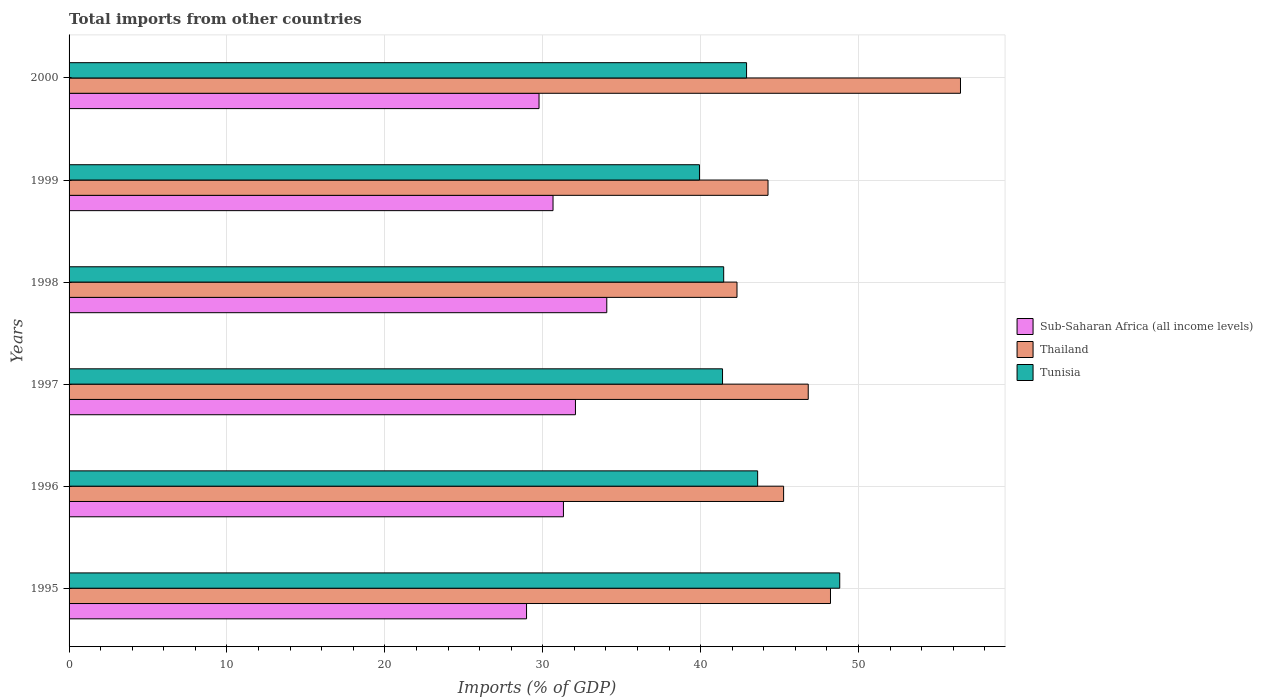How many different coloured bars are there?
Keep it short and to the point. 3. How many groups of bars are there?
Provide a short and direct response. 6. Are the number of bars per tick equal to the number of legend labels?
Keep it short and to the point. Yes. How many bars are there on the 1st tick from the top?
Ensure brevity in your answer.  3. What is the label of the 5th group of bars from the top?
Your answer should be compact. 1996. What is the total imports in Thailand in 1999?
Your answer should be compact. 44.27. Across all years, what is the maximum total imports in Sub-Saharan Africa (all income levels)?
Offer a terse response. 34.06. Across all years, what is the minimum total imports in Sub-Saharan Africa (all income levels)?
Provide a short and direct response. 28.97. In which year was the total imports in Thailand maximum?
Give a very brief answer. 2000. In which year was the total imports in Sub-Saharan Africa (all income levels) minimum?
Your response must be concise. 1995. What is the total total imports in Sub-Saharan Africa (all income levels) in the graph?
Your answer should be very brief. 186.83. What is the difference between the total imports in Thailand in 1995 and that in 1997?
Your response must be concise. 1.41. What is the difference between the total imports in Sub-Saharan Africa (all income levels) in 1996 and the total imports in Thailand in 1998?
Your answer should be very brief. -10.99. What is the average total imports in Tunisia per year?
Make the answer very short. 43.02. In the year 1999, what is the difference between the total imports in Sub-Saharan Africa (all income levels) and total imports in Tunisia?
Offer a terse response. -9.27. What is the ratio of the total imports in Sub-Saharan Africa (all income levels) in 1997 to that in 2000?
Provide a short and direct response. 1.08. Is the total imports in Thailand in 1998 less than that in 1999?
Your response must be concise. Yes. What is the difference between the highest and the second highest total imports in Sub-Saharan Africa (all income levels)?
Your answer should be compact. 1.98. What is the difference between the highest and the lowest total imports in Sub-Saharan Africa (all income levels)?
Your answer should be compact. 5.08. What does the 1st bar from the top in 2000 represents?
Offer a terse response. Tunisia. What does the 2nd bar from the bottom in 1996 represents?
Provide a short and direct response. Thailand. How many years are there in the graph?
Your answer should be compact. 6. Are the values on the major ticks of X-axis written in scientific E-notation?
Offer a terse response. No. Does the graph contain grids?
Provide a short and direct response. Yes. How many legend labels are there?
Offer a very short reply. 3. How are the legend labels stacked?
Make the answer very short. Vertical. What is the title of the graph?
Keep it short and to the point. Total imports from other countries. Does "Sub-Saharan Africa (developing only)" appear as one of the legend labels in the graph?
Your answer should be very brief. No. What is the label or title of the X-axis?
Make the answer very short. Imports (% of GDP). What is the Imports (% of GDP) in Sub-Saharan Africa (all income levels) in 1995?
Give a very brief answer. 28.97. What is the Imports (% of GDP) in Thailand in 1995?
Your answer should be compact. 48.22. What is the Imports (% of GDP) in Tunisia in 1995?
Your answer should be very brief. 48.81. What is the Imports (% of GDP) in Sub-Saharan Africa (all income levels) in 1996?
Give a very brief answer. 31.31. What is the Imports (% of GDP) in Thailand in 1996?
Provide a short and direct response. 45.26. What is the Imports (% of GDP) of Tunisia in 1996?
Offer a very short reply. 43.61. What is the Imports (% of GDP) of Sub-Saharan Africa (all income levels) in 1997?
Keep it short and to the point. 32.07. What is the Imports (% of GDP) of Thailand in 1997?
Your response must be concise. 46.81. What is the Imports (% of GDP) in Tunisia in 1997?
Provide a succinct answer. 41.39. What is the Imports (% of GDP) of Sub-Saharan Africa (all income levels) in 1998?
Offer a terse response. 34.06. What is the Imports (% of GDP) in Thailand in 1998?
Your response must be concise. 42.3. What is the Imports (% of GDP) in Tunisia in 1998?
Make the answer very short. 41.46. What is the Imports (% of GDP) of Sub-Saharan Africa (all income levels) in 1999?
Offer a terse response. 30.65. What is the Imports (% of GDP) in Thailand in 1999?
Ensure brevity in your answer.  44.27. What is the Imports (% of GDP) in Tunisia in 1999?
Keep it short and to the point. 39.93. What is the Imports (% of GDP) in Sub-Saharan Africa (all income levels) in 2000?
Offer a terse response. 29.77. What is the Imports (% of GDP) of Thailand in 2000?
Offer a terse response. 56.46. What is the Imports (% of GDP) of Tunisia in 2000?
Offer a very short reply. 42.91. Across all years, what is the maximum Imports (% of GDP) in Sub-Saharan Africa (all income levels)?
Ensure brevity in your answer.  34.06. Across all years, what is the maximum Imports (% of GDP) in Thailand?
Provide a succinct answer. 56.46. Across all years, what is the maximum Imports (% of GDP) in Tunisia?
Your answer should be very brief. 48.81. Across all years, what is the minimum Imports (% of GDP) in Sub-Saharan Africa (all income levels)?
Give a very brief answer. 28.97. Across all years, what is the minimum Imports (% of GDP) in Thailand?
Offer a terse response. 42.3. Across all years, what is the minimum Imports (% of GDP) of Tunisia?
Your answer should be compact. 39.93. What is the total Imports (% of GDP) of Sub-Saharan Africa (all income levels) in the graph?
Ensure brevity in your answer.  186.83. What is the total Imports (% of GDP) of Thailand in the graph?
Provide a short and direct response. 283.32. What is the total Imports (% of GDP) of Tunisia in the graph?
Your answer should be compact. 258.1. What is the difference between the Imports (% of GDP) of Sub-Saharan Africa (all income levels) in 1995 and that in 1996?
Provide a short and direct response. -2.34. What is the difference between the Imports (% of GDP) of Thailand in 1995 and that in 1996?
Your answer should be very brief. 2.97. What is the difference between the Imports (% of GDP) in Tunisia in 1995 and that in 1996?
Provide a short and direct response. 5.2. What is the difference between the Imports (% of GDP) in Sub-Saharan Africa (all income levels) in 1995 and that in 1997?
Your answer should be compact. -3.1. What is the difference between the Imports (% of GDP) of Thailand in 1995 and that in 1997?
Offer a very short reply. 1.41. What is the difference between the Imports (% of GDP) in Tunisia in 1995 and that in 1997?
Give a very brief answer. 7.42. What is the difference between the Imports (% of GDP) in Sub-Saharan Africa (all income levels) in 1995 and that in 1998?
Make the answer very short. -5.08. What is the difference between the Imports (% of GDP) in Thailand in 1995 and that in 1998?
Your answer should be compact. 5.92. What is the difference between the Imports (% of GDP) of Tunisia in 1995 and that in 1998?
Offer a very short reply. 7.35. What is the difference between the Imports (% of GDP) in Sub-Saharan Africa (all income levels) in 1995 and that in 1999?
Provide a succinct answer. -1.68. What is the difference between the Imports (% of GDP) of Thailand in 1995 and that in 1999?
Your answer should be very brief. 3.96. What is the difference between the Imports (% of GDP) of Tunisia in 1995 and that in 1999?
Make the answer very short. 8.88. What is the difference between the Imports (% of GDP) of Sub-Saharan Africa (all income levels) in 1995 and that in 2000?
Keep it short and to the point. -0.79. What is the difference between the Imports (% of GDP) of Thailand in 1995 and that in 2000?
Keep it short and to the point. -8.23. What is the difference between the Imports (% of GDP) of Tunisia in 1995 and that in 2000?
Provide a succinct answer. 5.9. What is the difference between the Imports (% of GDP) in Sub-Saharan Africa (all income levels) in 1996 and that in 1997?
Keep it short and to the point. -0.76. What is the difference between the Imports (% of GDP) in Thailand in 1996 and that in 1997?
Your answer should be compact. -1.56. What is the difference between the Imports (% of GDP) in Tunisia in 1996 and that in 1997?
Ensure brevity in your answer.  2.22. What is the difference between the Imports (% of GDP) of Sub-Saharan Africa (all income levels) in 1996 and that in 1998?
Your answer should be very brief. -2.74. What is the difference between the Imports (% of GDP) of Thailand in 1996 and that in 1998?
Ensure brevity in your answer.  2.95. What is the difference between the Imports (% of GDP) of Tunisia in 1996 and that in 1998?
Provide a short and direct response. 2.15. What is the difference between the Imports (% of GDP) of Sub-Saharan Africa (all income levels) in 1996 and that in 1999?
Provide a succinct answer. 0.66. What is the difference between the Imports (% of GDP) in Thailand in 1996 and that in 1999?
Provide a short and direct response. 0.99. What is the difference between the Imports (% of GDP) of Tunisia in 1996 and that in 1999?
Offer a terse response. 3.68. What is the difference between the Imports (% of GDP) in Sub-Saharan Africa (all income levels) in 1996 and that in 2000?
Your response must be concise. 1.55. What is the difference between the Imports (% of GDP) in Thailand in 1996 and that in 2000?
Keep it short and to the point. -11.2. What is the difference between the Imports (% of GDP) of Tunisia in 1996 and that in 2000?
Offer a terse response. 0.7. What is the difference between the Imports (% of GDP) in Sub-Saharan Africa (all income levels) in 1997 and that in 1998?
Your answer should be very brief. -1.98. What is the difference between the Imports (% of GDP) of Thailand in 1997 and that in 1998?
Give a very brief answer. 4.51. What is the difference between the Imports (% of GDP) of Tunisia in 1997 and that in 1998?
Provide a succinct answer. -0.07. What is the difference between the Imports (% of GDP) of Sub-Saharan Africa (all income levels) in 1997 and that in 1999?
Keep it short and to the point. 1.42. What is the difference between the Imports (% of GDP) in Thailand in 1997 and that in 1999?
Make the answer very short. 2.55. What is the difference between the Imports (% of GDP) of Tunisia in 1997 and that in 1999?
Your answer should be very brief. 1.46. What is the difference between the Imports (% of GDP) in Sub-Saharan Africa (all income levels) in 1997 and that in 2000?
Offer a terse response. 2.31. What is the difference between the Imports (% of GDP) of Thailand in 1997 and that in 2000?
Your response must be concise. -9.64. What is the difference between the Imports (% of GDP) in Tunisia in 1997 and that in 2000?
Your answer should be compact. -1.52. What is the difference between the Imports (% of GDP) of Sub-Saharan Africa (all income levels) in 1998 and that in 1999?
Offer a very short reply. 3.4. What is the difference between the Imports (% of GDP) of Thailand in 1998 and that in 1999?
Offer a very short reply. -1.96. What is the difference between the Imports (% of GDP) of Tunisia in 1998 and that in 1999?
Your answer should be compact. 1.53. What is the difference between the Imports (% of GDP) in Sub-Saharan Africa (all income levels) in 1998 and that in 2000?
Your response must be concise. 4.29. What is the difference between the Imports (% of GDP) of Thailand in 1998 and that in 2000?
Offer a terse response. -14.15. What is the difference between the Imports (% of GDP) in Tunisia in 1998 and that in 2000?
Keep it short and to the point. -1.45. What is the difference between the Imports (% of GDP) in Sub-Saharan Africa (all income levels) in 1999 and that in 2000?
Provide a short and direct response. 0.89. What is the difference between the Imports (% of GDP) in Thailand in 1999 and that in 2000?
Ensure brevity in your answer.  -12.19. What is the difference between the Imports (% of GDP) in Tunisia in 1999 and that in 2000?
Provide a short and direct response. -2.98. What is the difference between the Imports (% of GDP) in Sub-Saharan Africa (all income levels) in 1995 and the Imports (% of GDP) in Thailand in 1996?
Give a very brief answer. -16.28. What is the difference between the Imports (% of GDP) in Sub-Saharan Africa (all income levels) in 1995 and the Imports (% of GDP) in Tunisia in 1996?
Ensure brevity in your answer.  -14.64. What is the difference between the Imports (% of GDP) of Thailand in 1995 and the Imports (% of GDP) of Tunisia in 1996?
Offer a very short reply. 4.61. What is the difference between the Imports (% of GDP) of Sub-Saharan Africa (all income levels) in 1995 and the Imports (% of GDP) of Thailand in 1997?
Your response must be concise. -17.84. What is the difference between the Imports (% of GDP) in Sub-Saharan Africa (all income levels) in 1995 and the Imports (% of GDP) in Tunisia in 1997?
Provide a succinct answer. -12.41. What is the difference between the Imports (% of GDP) in Thailand in 1995 and the Imports (% of GDP) in Tunisia in 1997?
Make the answer very short. 6.84. What is the difference between the Imports (% of GDP) of Sub-Saharan Africa (all income levels) in 1995 and the Imports (% of GDP) of Thailand in 1998?
Offer a terse response. -13.33. What is the difference between the Imports (% of GDP) in Sub-Saharan Africa (all income levels) in 1995 and the Imports (% of GDP) in Tunisia in 1998?
Give a very brief answer. -12.49. What is the difference between the Imports (% of GDP) of Thailand in 1995 and the Imports (% of GDP) of Tunisia in 1998?
Your response must be concise. 6.76. What is the difference between the Imports (% of GDP) in Sub-Saharan Africa (all income levels) in 1995 and the Imports (% of GDP) in Thailand in 1999?
Offer a terse response. -15.29. What is the difference between the Imports (% of GDP) in Sub-Saharan Africa (all income levels) in 1995 and the Imports (% of GDP) in Tunisia in 1999?
Make the answer very short. -10.95. What is the difference between the Imports (% of GDP) of Thailand in 1995 and the Imports (% of GDP) of Tunisia in 1999?
Provide a succinct answer. 8.3. What is the difference between the Imports (% of GDP) of Sub-Saharan Africa (all income levels) in 1995 and the Imports (% of GDP) of Thailand in 2000?
Keep it short and to the point. -27.48. What is the difference between the Imports (% of GDP) of Sub-Saharan Africa (all income levels) in 1995 and the Imports (% of GDP) of Tunisia in 2000?
Ensure brevity in your answer.  -13.93. What is the difference between the Imports (% of GDP) in Thailand in 1995 and the Imports (% of GDP) in Tunisia in 2000?
Provide a short and direct response. 5.31. What is the difference between the Imports (% of GDP) of Sub-Saharan Africa (all income levels) in 1996 and the Imports (% of GDP) of Thailand in 1997?
Give a very brief answer. -15.5. What is the difference between the Imports (% of GDP) in Sub-Saharan Africa (all income levels) in 1996 and the Imports (% of GDP) in Tunisia in 1997?
Your answer should be compact. -10.08. What is the difference between the Imports (% of GDP) of Thailand in 1996 and the Imports (% of GDP) of Tunisia in 1997?
Provide a succinct answer. 3.87. What is the difference between the Imports (% of GDP) in Sub-Saharan Africa (all income levels) in 1996 and the Imports (% of GDP) in Thailand in 1998?
Offer a very short reply. -10.99. What is the difference between the Imports (% of GDP) of Sub-Saharan Africa (all income levels) in 1996 and the Imports (% of GDP) of Tunisia in 1998?
Make the answer very short. -10.15. What is the difference between the Imports (% of GDP) in Thailand in 1996 and the Imports (% of GDP) in Tunisia in 1998?
Your answer should be compact. 3.8. What is the difference between the Imports (% of GDP) of Sub-Saharan Africa (all income levels) in 1996 and the Imports (% of GDP) of Thailand in 1999?
Keep it short and to the point. -12.96. What is the difference between the Imports (% of GDP) in Sub-Saharan Africa (all income levels) in 1996 and the Imports (% of GDP) in Tunisia in 1999?
Your response must be concise. -8.61. What is the difference between the Imports (% of GDP) of Thailand in 1996 and the Imports (% of GDP) of Tunisia in 1999?
Provide a short and direct response. 5.33. What is the difference between the Imports (% of GDP) of Sub-Saharan Africa (all income levels) in 1996 and the Imports (% of GDP) of Thailand in 2000?
Provide a succinct answer. -25.15. What is the difference between the Imports (% of GDP) of Sub-Saharan Africa (all income levels) in 1996 and the Imports (% of GDP) of Tunisia in 2000?
Provide a succinct answer. -11.6. What is the difference between the Imports (% of GDP) of Thailand in 1996 and the Imports (% of GDP) of Tunisia in 2000?
Offer a terse response. 2.35. What is the difference between the Imports (% of GDP) of Sub-Saharan Africa (all income levels) in 1997 and the Imports (% of GDP) of Thailand in 1998?
Keep it short and to the point. -10.23. What is the difference between the Imports (% of GDP) of Sub-Saharan Africa (all income levels) in 1997 and the Imports (% of GDP) of Tunisia in 1998?
Provide a succinct answer. -9.39. What is the difference between the Imports (% of GDP) in Thailand in 1997 and the Imports (% of GDP) in Tunisia in 1998?
Your answer should be compact. 5.36. What is the difference between the Imports (% of GDP) of Sub-Saharan Africa (all income levels) in 1997 and the Imports (% of GDP) of Thailand in 1999?
Keep it short and to the point. -12.2. What is the difference between the Imports (% of GDP) of Sub-Saharan Africa (all income levels) in 1997 and the Imports (% of GDP) of Tunisia in 1999?
Your answer should be compact. -7.85. What is the difference between the Imports (% of GDP) of Thailand in 1997 and the Imports (% of GDP) of Tunisia in 1999?
Provide a succinct answer. 6.89. What is the difference between the Imports (% of GDP) of Sub-Saharan Africa (all income levels) in 1997 and the Imports (% of GDP) of Thailand in 2000?
Ensure brevity in your answer.  -24.39. What is the difference between the Imports (% of GDP) of Sub-Saharan Africa (all income levels) in 1997 and the Imports (% of GDP) of Tunisia in 2000?
Provide a succinct answer. -10.84. What is the difference between the Imports (% of GDP) in Thailand in 1997 and the Imports (% of GDP) in Tunisia in 2000?
Ensure brevity in your answer.  3.91. What is the difference between the Imports (% of GDP) of Sub-Saharan Africa (all income levels) in 1998 and the Imports (% of GDP) of Thailand in 1999?
Your answer should be compact. -10.21. What is the difference between the Imports (% of GDP) in Sub-Saharan Africa (all income levels) in 1998 and the Imports (% of GDP) in Tunisia in 1999?
Keep it short and to the point. -5.87. What is the difference between the Imports (% of GDP) of Thailand in 1998 and the Imports (% of GDP) of Tunisia in 1999?
Offer a very short reply. 2.38. What is the difference between the Imports (% of GDP) of Sub-Saharan Africa (all income levels) in 1998 and the Imports (% of GDP) of Thailand in 2000?
Provide a short and direct response. -22.4. What is the difference between the Imports (% of GDP) of Sub-Saharan Africa (all income levels) in 1998 and the Imports (% of GDP) of Tunisia in 2000?
Ensure brevity in your answer.  -8.85. What is the difference between the Imports (% of GDP) in Thailand in 1998 and the Imports (% of GDP) in Tunisia in 2000?
Provide a short and direct response. -0.61. What is the difference between the Imports (% of GDP) of Sub-Saharan Africa (all income levels) in 1999 and the Imports (% of GDP) of Thailand in 2000?
Make the answer very short. -25.81. What is the difference between the Imports (% of GDP) of Sub-Saharan Africa (all income levels) in 1999 and the Imports (% of GDP) of Tunisia in 2000?
Your answer should be compact. -12.26. What is the difference between the Imports (% of GDP) in Thailand in 1999 and the Imports (% of GDP) in Tunisia in 2000?
Offer a very short reply. 1.36. What is the average Imports (% of GDP) in Sub-Saharan Africa (all income levels) per year?
Ensure brevity in your answer.  31.14. What is the average Imports (% of GDP) of Thailand per year?
Offer a very short reply. 47.22. What is the average Imports (% of GDP) of Tunisia per year?
Your answer should be compact. 43.02. In the year 1995, what is the difference between the Imports (% of GDP) of Sub-Saharan Africa (all income levels) and Imports (% of GDP) of Thailand?
Provide a short and direct response. -19.25. In the year 1995, what is the difference between the Imports (% of GDP) in Sub-Saharan Africa (all income levels) and Imports (% of GDP) in Tunisia?
Offer a very short reply. -19.84. In the year 1995, what is the difference between the Imports (% of GDP) of Thailand and Imports (% of GDP) of Tunisia?
Provide a succinct answer. -0.59. In the year 1996, what is the difference between the Imports (% of GDP) of Sub-Saharan Africa (all income levels) and Imports (% of GDP) of Thailand?
Make the answer very short. -13.94. In the year 1996, what is the difference between the Imports (% of GDP) of Sub-Saharan Africa (all income levels) and Imports (% of GDP) of Tunisia?
Provide a succinct answer. -12.3. In the year 1996, what is the difference between the Imports (% of GDP) in Thailand and Imports (% of GDP) in Tunisia?
Your answer should be compact. 1.64. In the year 1997, what is the difference between the Imports (% of GDP) in Sub-Saharan Africa (all income levels) and Imports (% of GDP) in Thailand?
Ensure brevity in your answer.  -14.74. In the year 1997, what is the difference between the Imports (% of GDP) in Sub-Saharan Africa (all income levels) and Imports (% of GDP) in Tunisia?
Keep it short and to the point. -9.31. In the year 1997, what is the difference between the Imports (% of GDP) of Thailand and Imports (% of GDP) of Tunisia?
Offer a very short reply. 5.43. In the year 1998, what is the difference between the Imports (% of GDP) of Sub-Saharan Africa (all income levels) and Imports (% of GDP) of Thailand?
Make the answer very short. -8.25. In the year 1998, what is the difference between the Imports (% of GDP) in Sub-Saharan Africa (all income levels) and Imports (% of GDP) in Tunisia?
Your answer should be very brief. -7.4. In the year 1998, what is the difference between the Imports (% of GDP) of Thailand and Imports (% of GDP) of Tunisia?
Your response must be concise. 0.84. In the year 1999, what is the difference between the Imports (% of GDP) in Sub-Saharan Africa (all income levels) and Imports (% of GDP) in Thailand?
Keep it short and to the point. -13.62. In the year 1999, what is the difference between the Imports (% of GDP) of Sub-Saharan Africa (all income levels) and Imports (% of GDP) of Tunisia?
Provide a succinct answer. -9.27. In the year 1999, what is the difference between the Imports (% of GDP) in Thailand and Imports (% of GDP) in Tunisia?
Offer a terse response. 4.34. In the year 2000, what is the difference between the Imports (% of GDP) of Sub-Saharan Africa (all income levels) and Imports (% of GDP) of Thailand?
Offer a terse response. -26.69. In the year 2000, what is the difference between the Imports (% of GDP) in Sub-Saharan Africa (all income levels) and Imports (% of GDP) in Tunisia?
Your answer should be compact. -13.14. In the year 2000, what is the difference between the Imports (% of GDP) in Thailand and Imports (% of GDP) in Tunisia?
Ensure brevity in your answer.  13.55. What is the ratio of the Imports (% of GDP) in Sub-Saharan Africa (all income levels) in 1995 to that in 1996?
Provide a succinct answer. 0.93. What is the ratio of the Imports (% of GDP) of Thailand in 1995 to that in 1996?
Give a very brief answer. 1.07. What is the ratio of the Imports (% of GDP) in Tunisia in 1995 to that in 1996?
Your response must be concise. 1.12. What is the ratio of the Imports (% of GDP) in Sub-Saharan Africa (all income levels) in 1995 to that in 1997?
Offer a very short reply. 0.9. What is the ratio of the Imports (% of GDP) in Thailand in 1995 to that in 1997?
Your answer should be very brief. 1.03. What is the ratio of the Imports (% of GDP) in Tunisia in 1995 to that in 1997?
Your answer should be compact. 1.18. What is the ratio of the Imports (% of GDP) in Sub-Saharan Africa (all income levels) in 1995 to that in 1998?
Keep it short and to the point. 0.85. What is the ratio of the Imports (% of GDP) of Thailand in 1995 to that in 1998?
Provide a succinct answer. 1.14. What is the ratio of the Imports (% of GDP) in Tunisia in 1995 to that in 1998?
Make the answer very short. 1.18. What is the ratio of the Imports (% of GDP) of Sub-Saharan Africa (all income levels) in 1995 to that in 1999?
Keep it short and to the point. 0.95. What is the ratio of the Imports (% of GDP) of Thailand in 1995 to that in 1999?
Keep it short and to the point. 1.09. What is the ratio of the Imports (% of GDP) in Tunisia in 1995 to that in 1999?
Make the answer very short. 1.22. What is the ratio of the Imports (% of GDP) of Sub-Saharan Africa (all income levels) in 1995 to that in 2000?
Your answer should be compact. 0.97. What is the ratio of the Imports (% of GDP) in Thailand in 1995 to that in 2000?
Offer a very short reply. 0.85. What is the ratio of the Imports (% of GDP) of Tunisia in 1995 to that in 2000?
Offer a terse response. 1.14. What is the ratio of the Imports (% of GDP) in Sub-Saharan Africa (all income levels) in 1996 to that in 1997?
Provide a short and direct response. 0.98. What is the ratio of the Imports (% of GDP) in Thailand in 1996 to that in 1997?
Your answer should be compact. 0.97. What is the ratio of the Imports (% of GDP) in Tunisia in 1996 to that in 1997?
Keep it short and to the point. 1.05. What is the ratio of the Imports (% of GDP) of Sub-Saharan Africa (all income levels) in 1996 to that in 1998?
Give a very brief answer. 0.92. What is the ratio of the Imports (% of GDP) in Thailand in 1996 to that in 1998?
Your answer should be compact. 1.07. What is the ratio of the Imports (% of GDP) in Tunisia in 1996 to that in 1998?
Provide a succinct answer. 1.05. What is the ratio of the Imports (% of GDP) of Sub-Saharan Africa (all income levels) in 1996 to that in 1999?
Your answer should be compact. 1.02. What is the ratio of the Imports (% of GDP) in Thailand in 1996 to that in 1999?
Give a very brief answer. 1.02. What is the ratio of the Imports (% of GDP) of Tunisia in 1996 to that in 1999?
Your response must be concise. 1.09. What is the ratio of the Imports (% of GDP) in Sub-Saharan Africa (all income levels) in 1996 to that in 2000?
Your response must be concise. 1.05. What is the ratio of the Imports (% of GDP) of Thailand in 1996 to that in 2000?
Make the answer very short. 0.8. What is the ratio of the Imports (% of GDP) in Tunisia in 1996 to that in 2000?
Make the answer very short. 1.02. What is the ratio of the Imports (% of GDP) in Sub-Saharan Africa (all income levels) in 1997 to that in 1998?
Offer a terse response. 0.94. What is the ratio of the Imports (% of GDP) of Thailand in 1997 to that in 1998?
Ensure brevity in your answer.  1.11. What is the ratio of the Imports (% of GDP) of Sub-Saharan Africa (all income levels) in 1997 to that in 1999?
Keep it short and to the point. 1.05. What is the ratio of the Imports (% of GDP) in Thailand in 1997 to that in 1999?
Offer a terse response. 1.06. What is the ratio of the Imports (% of GDP) of Tunisia in 1997 to that in 1999?
Offer a very short reply. 1.04. What is the ratio of the Imports (% of GDP) of Sub-Saharan Africa (all income levels) in 1997 to that in 2000?
Keep it short and to the point. 1.08. What is the ratio of the Imports (% of GDP) in Thailand in 1997 to that in 2000?
Provide a short and direct response. 0.83. What is the ratio of the Imports (% of GDP) of Tunisia in 1997 to that in 2000?
Ensure brevity in your answer.  0.96. What is the ratio of the Imports (% of GDP) of Thailand in 1998 to that in 1999?
Give a very brief answer. 0.96. What is the ratio of the Imports (% of GDP) in Tunisia in 1998 to that in 1999?
Your response must be concise. 1.04. What is the ratio of the Imports (% of GDP) in Sub-Saharan Africa (all income levels) in 1998 to that in 2000?
Your answer should be compact. 1.14. What is the ratio of the Imports (% of GDP) in Thailand in 1998 to that in 2000?
Offer a very short reply. 0.75. What is the ratio of the Imports (% of GDP) of Tunisia in 1998 to that in 2000?
Provide a short and direct response. 0.97. What is the ratio of the Imports (% of GDP) in Sub-Saharan Africa (all income levels) in 1999 to that in 2000?
Make the answer very short. 1.03. What is the ratio of the Imports (% of GDP) in Thailand in 1999 to that in 2000?
Provide a succinct answer. 0.78. What is the ratio of the Imports (% of GDP) in Tunisia in 1999 to that in 2000?
Your answer should be very brief. 0.93. What is the difference between the highest and the second highest Imports (% of GDP) in Sub-Saharan Africa (all income levels)?
Make the answer very short. 1.98. What is the difference between the highest and the second highest Imports (% of GDP) in Thailand?
Provide a succinct answer. 8.23. What is the difference between the highest and the second highest Imports (% of GDP) of Tunisia?
Offer a very short reply. 5.2. What is the difference between the highest and the lowest Imports (% of GDP) in Sub-Saharan Africa (all income levels)?
Provide a succinct answer. 5.08. What is the difference between the highest and the lowest Imports (% of GDP) in Thailand?
Offer a very short reply. 14.15. What is the difference between the highest and the lowest Imports (% of GDP) of Tunisia?
Your answer should be compact. 8.88. 